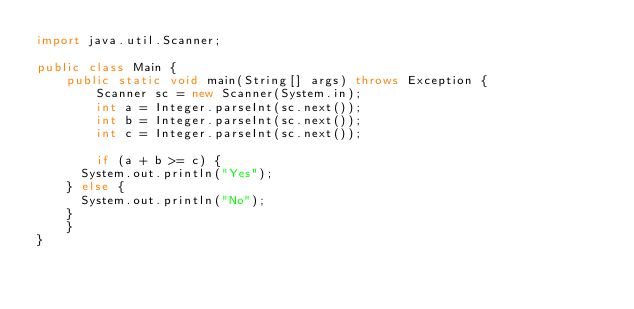<code> <loc_0><loc_0><loc_500><loc_500><_Java_>import java.util.Scanner;

public class Main {
    public static void main(String[] args) throws Exception {
        Scanner sc = new Scanner(System.in);
        int a = Integer.parseInt(sc.next());
        int b = Integer.parseInt(sc.next());
        int c = Integer.parseInt(sc.next());

        if (a + b >= c) {
			System.out.println("Yes");
		} else {
			System.out.println("No");
		}
    }
}</code> 